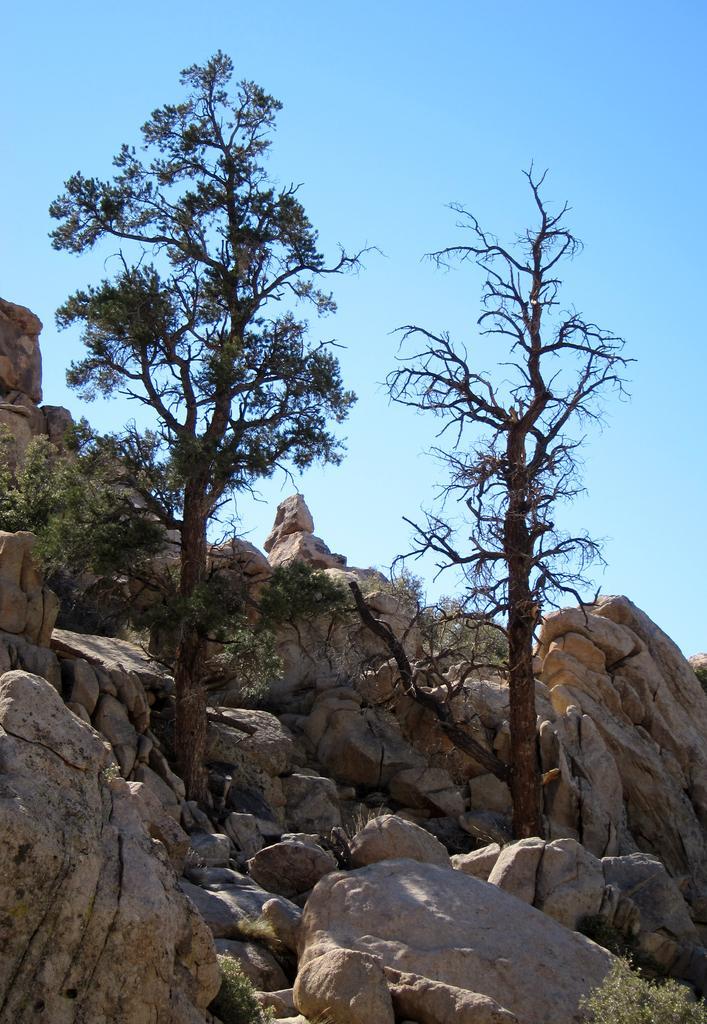In one or two sentences, can you explain what this image depicts? This picture shows few rocks and trees and a blue cloudy Sky. 